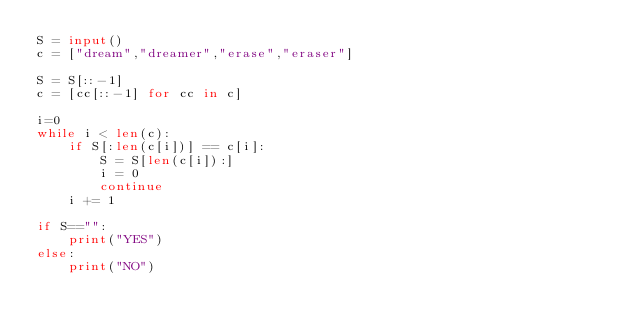<code> <loc_0><loc_0><loc_500><loc_500><_Python_>S = input()
c = ["dream","dreamer","erase","eraser"]

S = S[::-1]
c = [cc[::-1] for cc in c]

i=0
while i < len(c):
    if S[:len(c[i])] == c[i]:
        S = S[len(c[i]):]
        i = 0
        continue
    i += 1

if S=="":
    print("YES")
else:
    print("NO")
</code> 